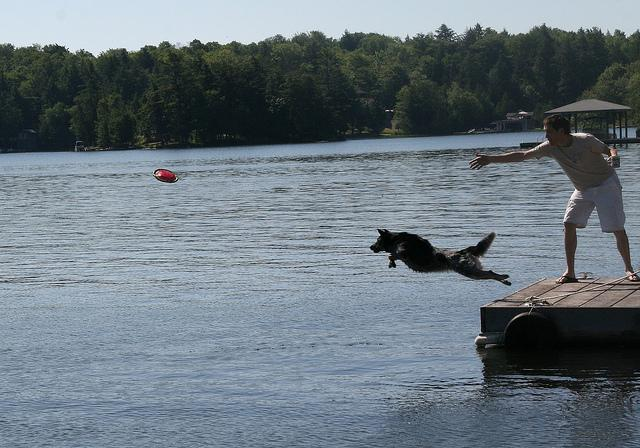What is the object called that the dog is jumping into the water after? Please explain your reasoning. frisbee. A frisbee attracts the dog easily. 